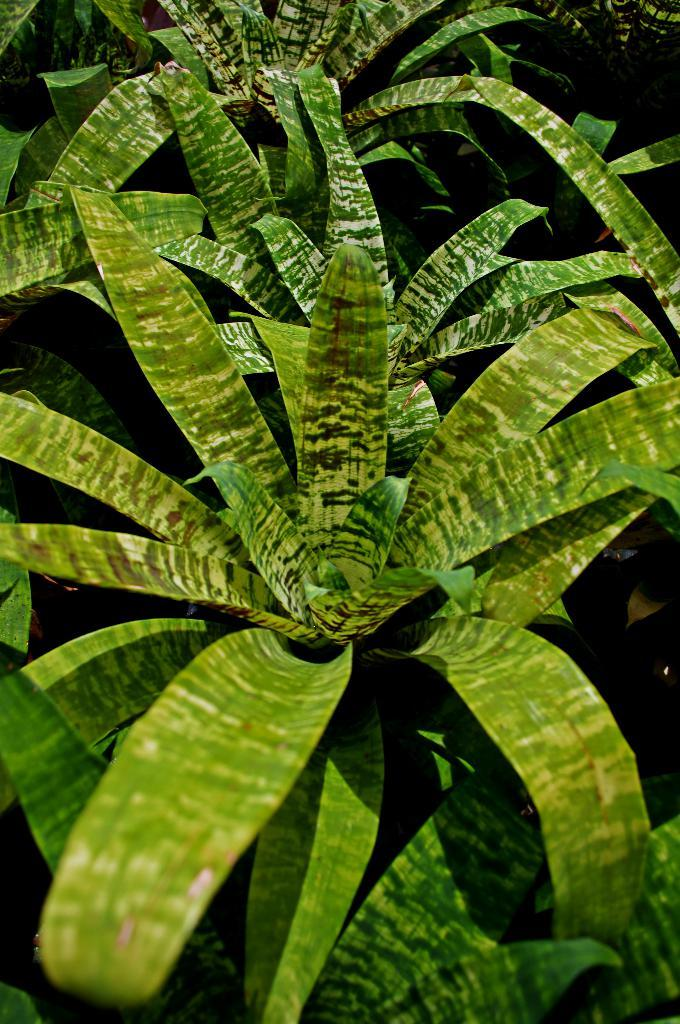What type of living organisms can be seen in the image? Plants can be seen in the image. Can you describe the lighting in the image? The image appears to be a bit dark. Where is the throne located in the image? There is no throne present in the image. What type of memory can be seen in the image? There is no memory present in the image, as it is a photograph and not a mental recollection. 